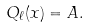<formula> <loc_0><loc_0><loc_500><loc_500>Q _ { \ell } ( x ) = A .</formula> 